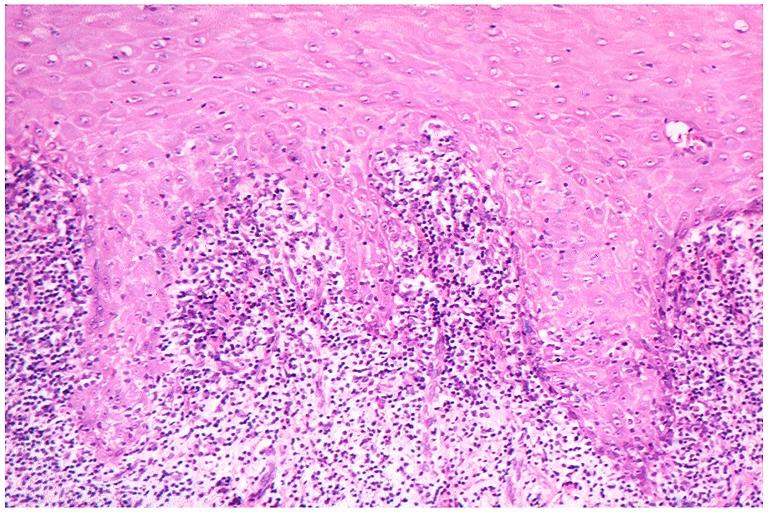what does this image show?
Answer the question using a single word or phrase. Lichen planus 